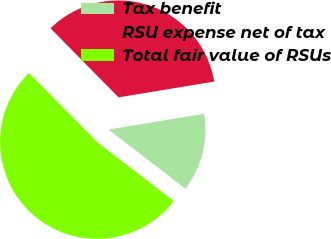Convert chart. <chart><loc_0><loc_0><loc_500><loc_500><pie_chart><fcel>Tax benefit<fcel>RSU expense net of tax<fcel>Total fair value of RSUs<nl><fcel>13.04%<fcel>34.78%<fcel>52.17%<nl></chart> 